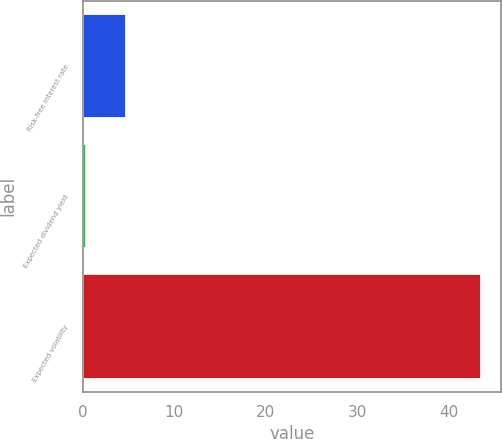<chart> <loc_0><loc_0><loc_500><loc_500><bar_chart><fcel>Risk-free interest rate<fcel>Expected dividend yield<fcel>Expected volatility<nl><fcel>4.71<fcel>0.4<fcel>43.5<nl></chart> 